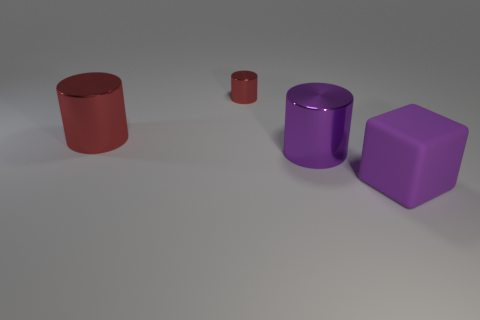Add 2 purple things. How many objects exist? 6 Subtract all cylinders. How many objects are left? 1 Add 3 large cylinders. How many large cylinders are left? 5 Add 3 red rubber balls. How many red rubber balls exist? 3 Subtract 0 yellow blocks. How many objects are left? 4 Subtract all purple matte objects. Subtract all big blocks. How many objects are left? 2 